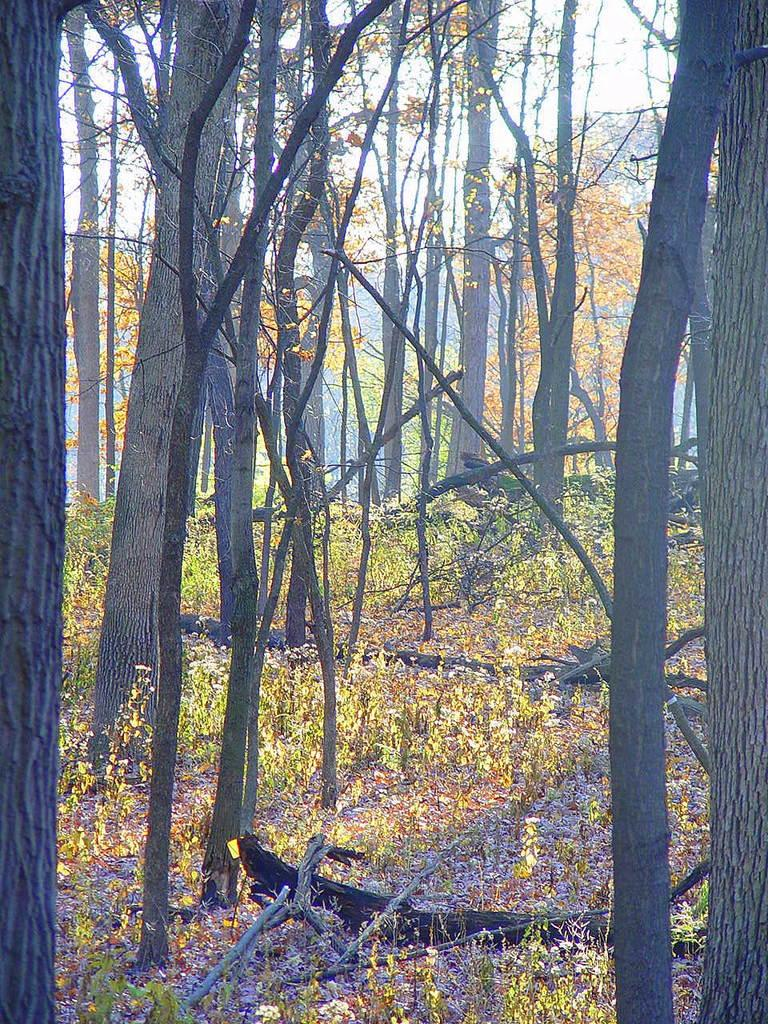What type of vegetation is present in the image? There are trees in the image. What type of ground cover is visible at the bottom of the image? There is grass at the bottom of the image. What part of the natural environment is visible in the background of the image? The sky is visible in the background of the image. How many mice can be seen in the image? There are no mice present in the image. What color are the eyes of the trees in the image? Trees do not have eyes, so this question cannot be answered. 